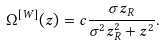Convert formula to latex. <formula><loc_0><loc_0><loc_500><loc_500>\Omega ^ { [ W ] } ( z ) = c \frac { \sigma z _ { R } } { \sigma ^ { 2 } z _ { R } ^ { 2 } + z ^ { 2 } } .</formula> 